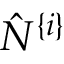Convert formula to latex. <formula><loc_0><loc_0><loc_500><loc_500>\hat { N } ^ { \{ i \} }</formula> 